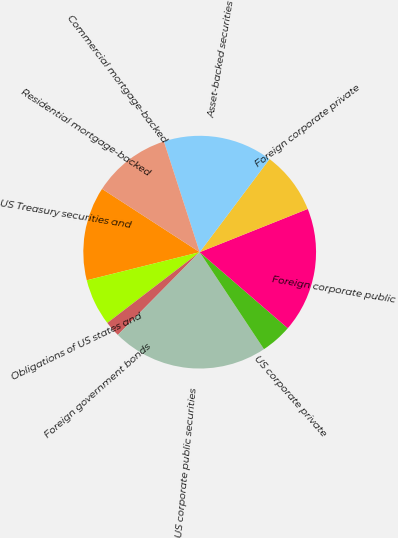Convert chart to OTSL. <chart><loc_0><loc_0><loc_500><loc_500><pie_chart><fcel>US Treasury securities and<fcel>Obligations of US states and<fcel>Foreign government bonds<fcel>US corporate public securities<fcel>US corporate private<fcel>Foreign corporate public<fcel>Foreign corporate private<fcel>Asset-backed securities<fcel>Commercial mortgage-backed<fcel>Residential mortgage-backed<nl><fcel>13.04%<fcel>6.52%<fcel>2.18%<fcel>21.73%<fcel>4.35%<fcel>17.39%<fcel>8.7%<fcel>15.22%<fcel>10.87%<fcel>0.0%<nl></chart> 